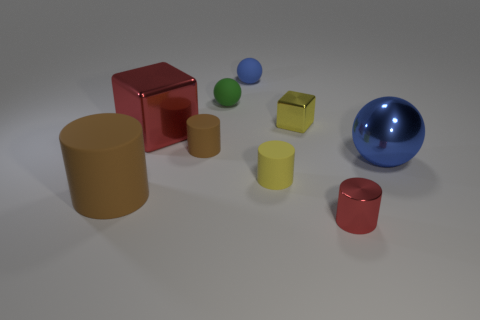How many tiny cylinders are there?
Your answer should be compact. 3. There is a large matte thing; does it have the same shape as the blue object that is behind the tiny yellow metallic block?
Give a very brief answer. No. Is the number of big rubber things that are left of the big brown matte cylinder less than the number of large objects left of the tiny green rubber object?
Offer a very short reply. Yes. Is the shape of the blue metal thing the same as the tiny green thing?
Offer a very short reply. Yes. What is the size of the yellow metallic block?
Keep it short and to the point. Small. There is a rubber cylinder that is both left of the small blue sphere and behind the big rubber thing; what color is it?
Keep it short and to the point. Brown. Are there more large gray cylinders than small rubber cylinders?
Ensure brevity in your answer.  No. What number of things are either big blue balls or cubes that are on the right side of the small blue matte object?
Your response must be concise. 2. Does the blue matte sphere have the same size as the red block?
Provide a short and direct response. No. Are there any big shiny things right of the red metallic cylinder?
Your answer should be compact. Yes. 